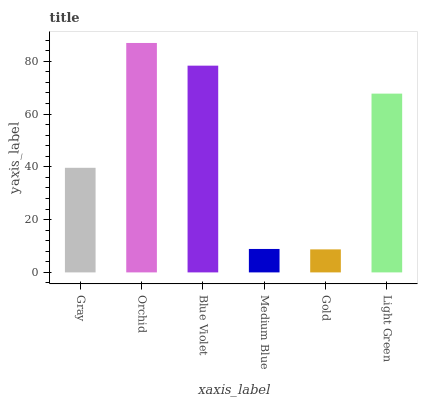Is Gold the minimum?
Answer yes or no. Yes. Is Orchid the maximum?
Answer yes or no. Yes. Is Blue Violet the minimum?
Answer yes or no. No. Is Blue Violet the maximum?
Answer yes or no. No. Is Orchid greater than Blue Violet?
Answer yes or no. Yes. Is Blue Violet less than Orchid?
Answer yes or no. Yes. Is Blue Violet greater than Orchid?
Answer yes or no. No. Is Orchid less than Blue Violet?
Answer yes or no. No. Is Light Green the high median?
Answer yes or no. Yes. Is Gray the low median?
Answer yes or no. Yes. Is Orchid the high median?
Answer yes or no. No. Is Orchid the low median?
Answer yes or no. No. 